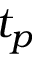<formula> <loc_0><loc_0><loc_500><loc_500>t _ { p }</formula> 